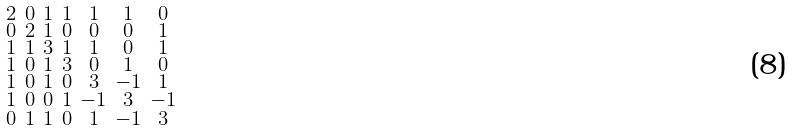Convert formula to latex. <formula><loc_0><loc_0><loc_500><loc_500>\begin{smallmatrix} 2 & 0 & 1 & 1 & 1 & 1 & 0 \\ 0 & 2 & 1 & 0 & 0 & 0 & 1 \\ 1 & 1 & 3 & 1 & 1 & 0 & 1 \\ 1 & 0 & 1 & 3 & 0 & 1 & 0 \\ 1 & 0 & 1 & 0 & 3 & - 1 & 1 \\ 1 & 0 & 0 & 1 & - 1 & 3 & - 1 \\ 0 & 1 & 1 & 0 & 1 & - 1 & 3 \end{smallmatrix}</formula> 